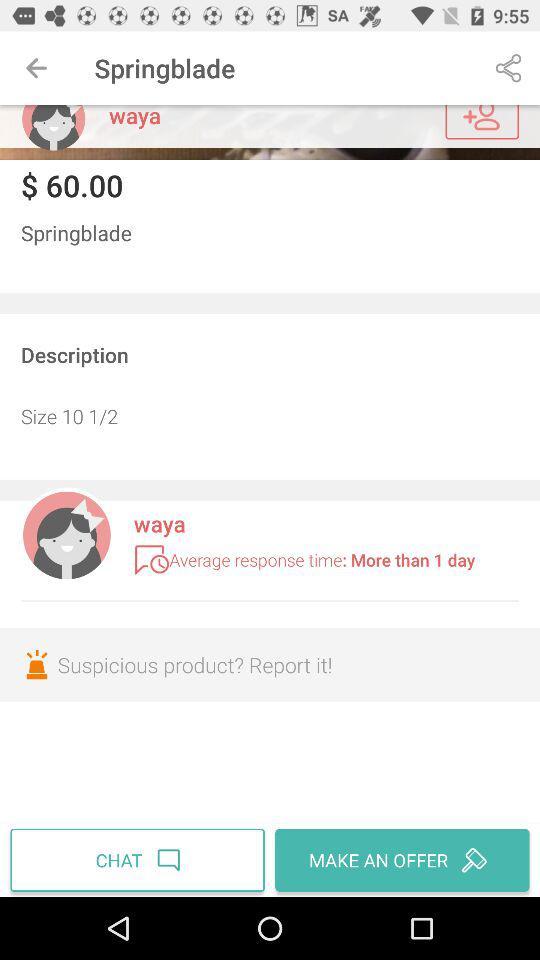What is the size? The size is 10 1/2. 